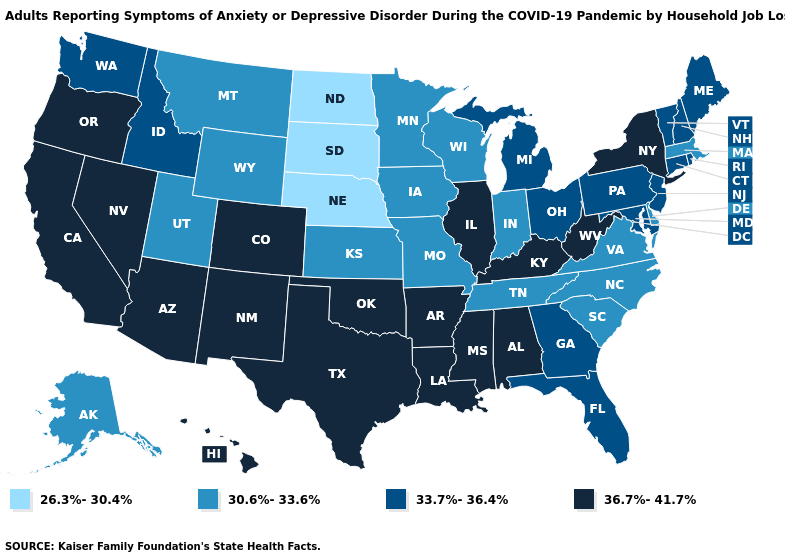Which states have the lowest value in the USA?
Quick response, please. Nebraska, North Dakota, South Dakota. Does Vermont have the same value as New Hampshire?
Short answer required. Yes. What is the lowest value in states that border Mississippi?
Quick response, please. 30.6%-33.6%. Name the states that have a value in the range 36.7%-41.7%?
Be succinct. Alabama, Arizona, Arkansas, California, Colorado, Hawaii, Illinois, Kentucky, Louisiana, Mississippi, Nevada, New Mexico, New York, Oklahoma, Oregon, Texas, West Virginia. Name the states that have a value in the range 30.6%-33.6%?
Quick response, please. Alaska, Delaware, Indiana, Iowa, Kansas, Massachusetts, Minnesota, Missouri, Montana, North Carolina, South Carolina, Tennessee, Utah, Virginia, Wisconsin, Wyoming. What is the highest value in the USA?
Short answer required. 36.7%-41.7%. Name the states that have a value in the range 33.7%-36.4%?
Keep it brief. Connecticut, Florida, Georgia, Idaho, Maine, Maryland, Michigan, New Hampshire, New Jersey, Ohio, Pennsylvania, Rhode Island, Vermont, Washington. What is the value of Virginia?
Short answer required. 30.6%-33.6%. What is the lowest value in the West?
Be succinct. 30.6%-33.6%. What is the value of North Carolina?
Answer briefly. 30.6%-33.6%. Name the states that have a value in the range 26.3%-30.4%?
Quick response, please. Nebraska, North Dakota, South Dakota. Name the states that have a value in the range 36.7%-41.7%?
Answer briefly. Alabama, Arizona, Arkansas, California, Colorado, Hawaii, Illinois, Kentucky, Louisiana, Mississippi, Nevada, New Mexico, New York, Oklahoma, Oregon, Texas, West Virginia. Name the states that have a value in the range 30.6%-33.6%?
Write a very short answer. Alaska, Delaware, Indiana, Iowa, Kansas, Massachusetts, Minnesota, Missouri, Montana, North Carolina, South Carolina, Tennessee, Utah, Virginia, Wisconsin, Wyoming. What is the value of Minnesota?
Give a very brief answer. 30.6%-33.6%. What is the lowest value in the USA?
Short answer required. 26.3%-30.4%. 